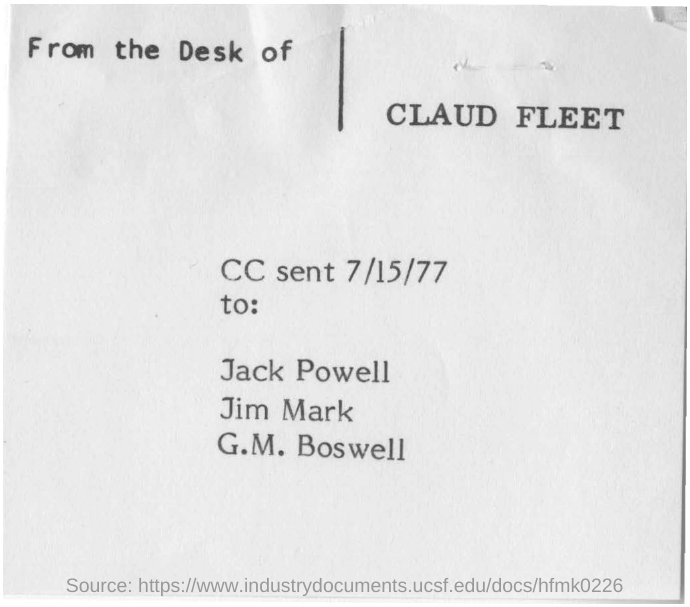Give some essential details in this illustration. The sender of this message is Claud Fleet. July 15th, 1977, is the date mentioned in the document. 